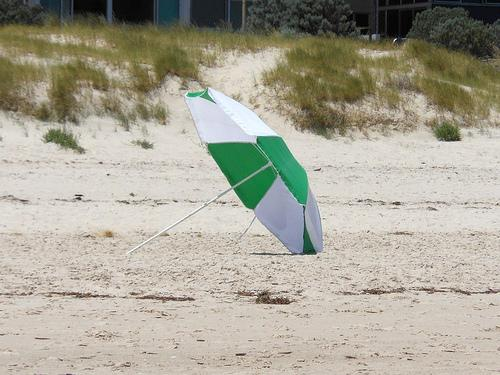In a brief sentence, state what the main attraction in the image is. The eye-catching green and white umbrella placed on the beach stands out in the image. Identify the setting and primary subject of the image. The setting is a beach, and the primary subject is a green and white umbrella. Mention the main object with its colors and where it is located in the image.  A green and white umbrella is situated on a white sandy beach. State the most noticeable feature in the image and mention if there is any background activity happening. A green and white umbrella is resting on the beach, with a sand hill and green shrubs on top of the hill in the background. List few objects or elements that you can see in the foreground of the image. Green and white umbrella, white pole, white strap, and small shadow on the ground from the umbrella. Mention the key elements and landscape in the image. A green and white umbrella lies on the beach, surrounded by tall sand dunes, green vegetation, and a faintly visible building in the distance. Describe the image by mentioning the essential elements, without repeating their color. An umbrella stands on the beach, surrounded by sand dunes with vegetation, and a distant building peeking above the hill. Describe the image by focusing on any shadows or objects located near the main subject. A green and white umbrella is on the beach with a modest shadow on the ground nearby, and a strap hanging from it. Provide a poetic description of the scene in the image. On the tranquil shore, a green and white umbrella tilts, casting a shadow upon golden sands, while hills and greenery whisper in the distance. Describe the main elements of the image, including natural features and objects. A green and white umbrella on the beach, tall sand dunes along with green vegetation, and a barely visible building in the background. 